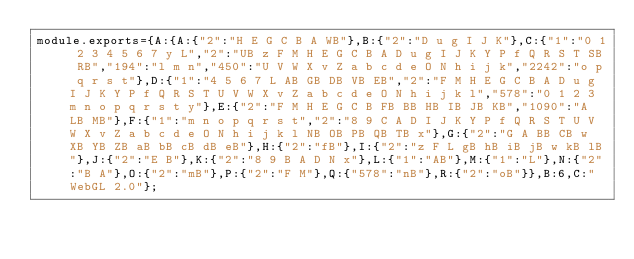<code> <loc_0><loc_0><loc_500><loc_500><_JavaScript_>module.exports={A:{A:{"2":"H E G C B A WB"},B:{"2":"D u g I J K"},C:{"1":"0 1 2 3 4 5 6 7 y L","2":"UB z F M H E G C B A D u g I J K Y P f Q R S T SB RB","194":"l m n","450":"U V W X v Z a b c d e O N h i j k","2242":"o p q r s t"},D:{"1":"4 5 6 7 L AB GB DB VB EB","2":"F M H E G C B A D u g I J K Y P f Q R S T U V W X v Z a b c d e O N h i j k l","578":"0 1 2 3 m n o p q r s t y"},E:{"2":"F M H E G C B FB BB HB IB JB KB","1090":"A LB MB"},F:{"1":"m n o p q r s t","2":"8 9 C A D I J K Y P f Q R S T U V W X v Z a b c d e O N h i j k l NB OB PB QB TB x"},G:{"2":"G A BB CB w XB YB ZB aB bB cB dB eB"},H:{"2":"fB"},I:{"2":"z F L gB hB iB jB w kB lB"},J:{"2":"E B"},K:{"2":"8 9 B A D N x"},L:{"1":"AB"},M:{"1":"L"},N:{"2":"B A"},O:{"2":"mB"},P:{"2":"F M"},Q:{"578":"nB"},R:{"2":"oB"}},B:6,C:"WebGL 2.0"};
</code> 